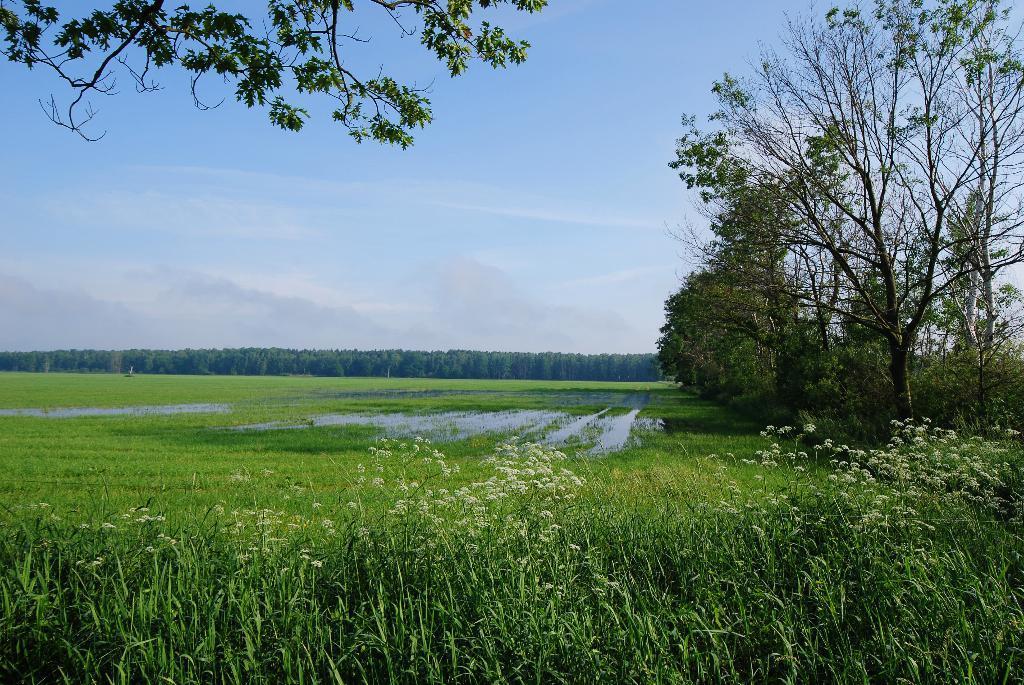Please provide a concise description of this image. In this image there is a field, on the right side and in the background there are trees and there is a sky. 